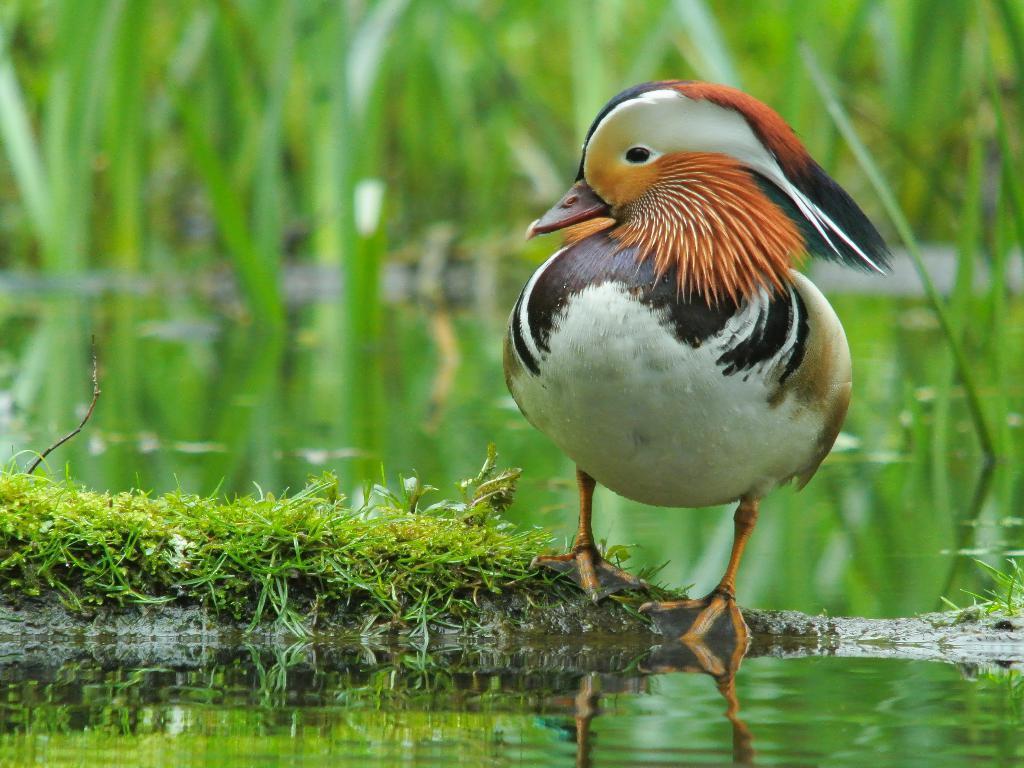Describe this image in one or two sentences. In this picture there is a bird on the right side of the image, on the wall and there is greenery in the image, there is water at the bottom side of the image. 